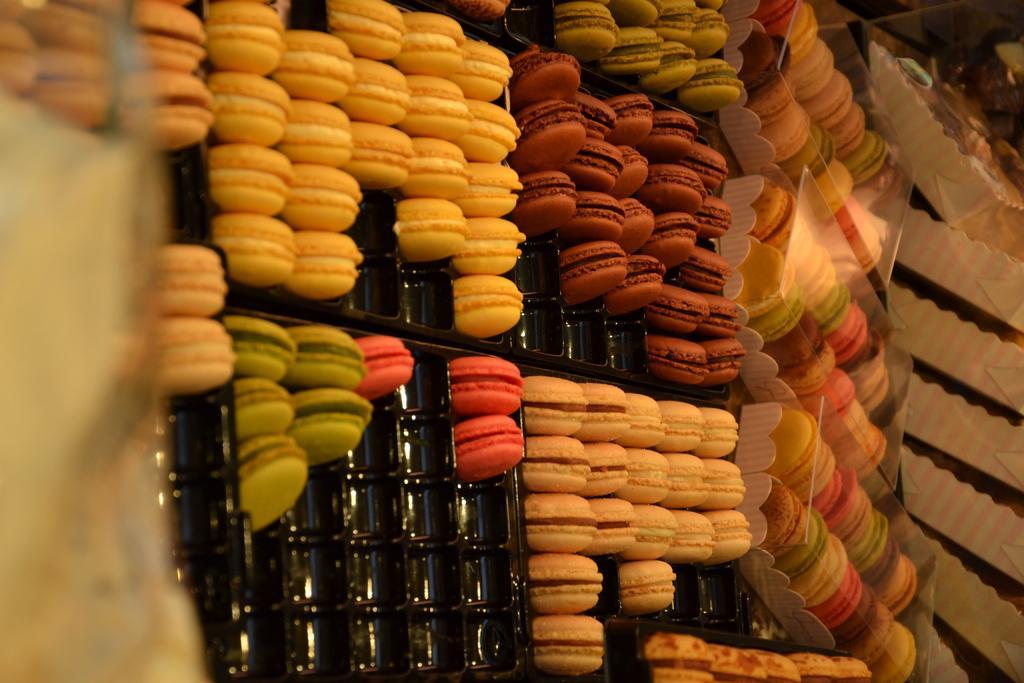Can you describe this image briefly? In this image, we can see some food items in trays. We can also see some paper covers on the right. 